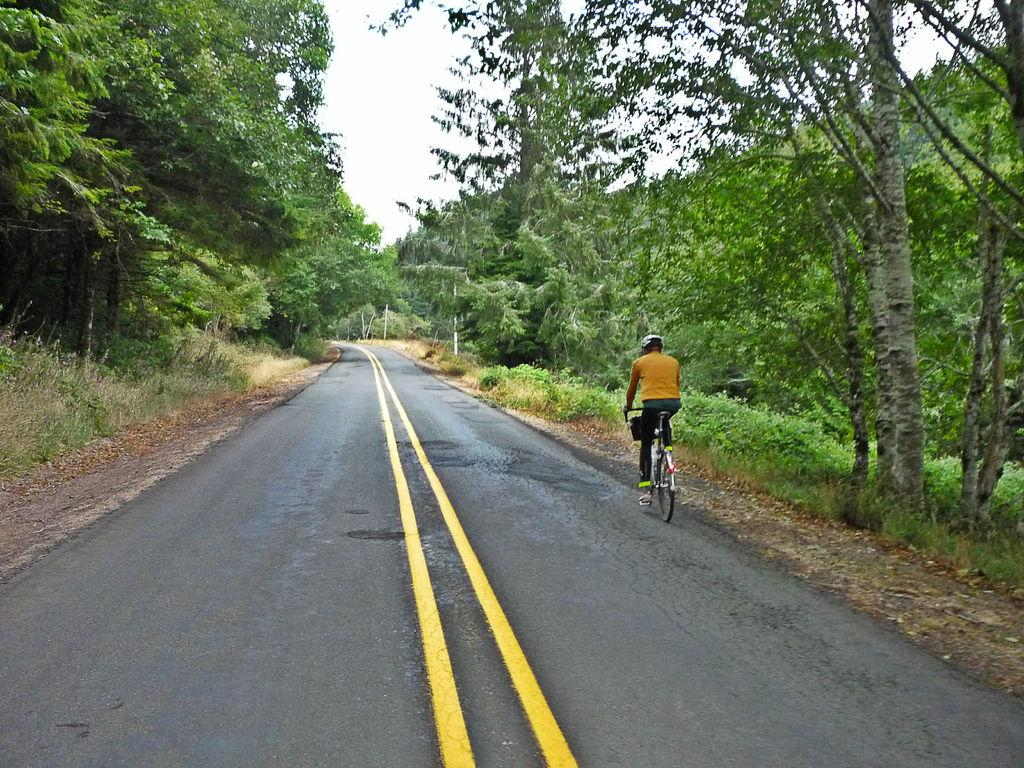What type of surface can be seen in the image? There is a road in the image. What type of vegetation is present in the image? There is grass and trees in the image. What part of the natural environment is visible in the image? The sky is visible in the image. What is the man in the image doing? The man is riding a bicycle. What protective gear is the man wearing? The man is wearing a helmet. What type of comfort can be seen in the image? There is no specific comfort item present in the image. What type of glove is the man wearing in the image? The man is not wearing any gloves in the image; he is only wearing a helmet. 